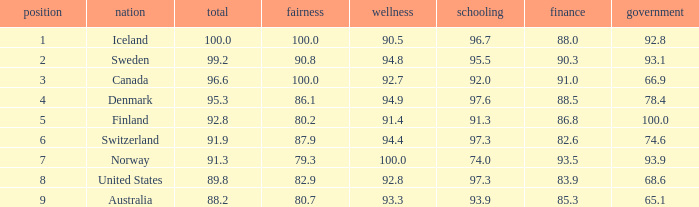What's the rank for iceland 1.0. 